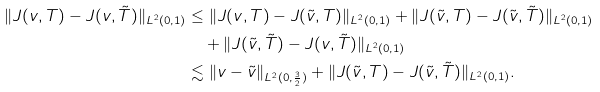<formula> <loc_0><loc_0><loc_500><loc_500>\| J ( v , T ) - J ( v , \tilde { T } ) \| _ { L ^ { 2 } ( 0 , 1 ) } & \leq \| J ( v , T ) - J ( \tilde { v } , T ) \| _ { L ^ { 2 } ( 0 , 1 ) } + \| J ( \tilde { v } , T ) - J ( \tilde { v } , \tilde { T } ) \| _ { L ^ { 2 } ( 0 , 1 ) } \\ & \quad + \| J ( \tilde { v } , \tilde { T } ) - J ( v , \tilde { T } ) \| _ { L ^ { 2 } ( 0 , 1 ) } \\ & \lesssim \| v - \tilde { v } \| _ { L ^ { 2 } ( 0 , \frac { 3 } { 2 } ) } + \| J ( \tilde { v } , T ) - J ( \tilde { v } , \tilde { T } ) \| _ { L ^ { 2 } ( 0 , 1 ) } .</formula> 